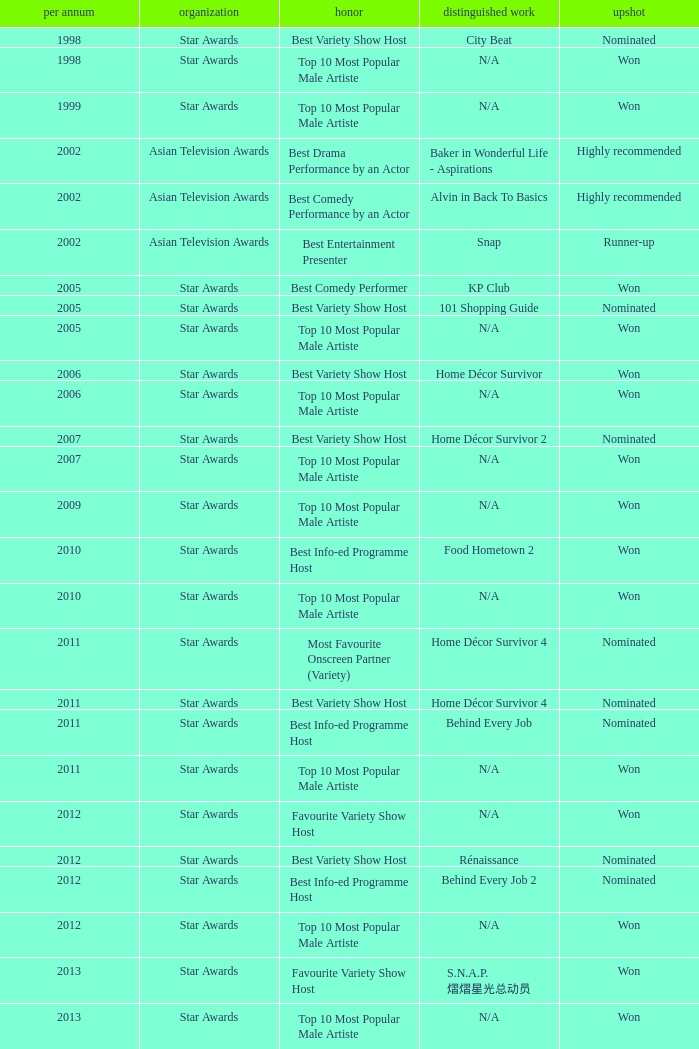What is the name of the award in a year more than 2005, and the Result of nominated? Best Variety Show Host, Most Favourite Onscreen Partner (Variety), Best Variety Show Host, Best Info-ed Programme Host, Best Variety Show Host, Best Info-ed Programme Host, Best Info-Ed Programme Host, Best Variety Show Host. 